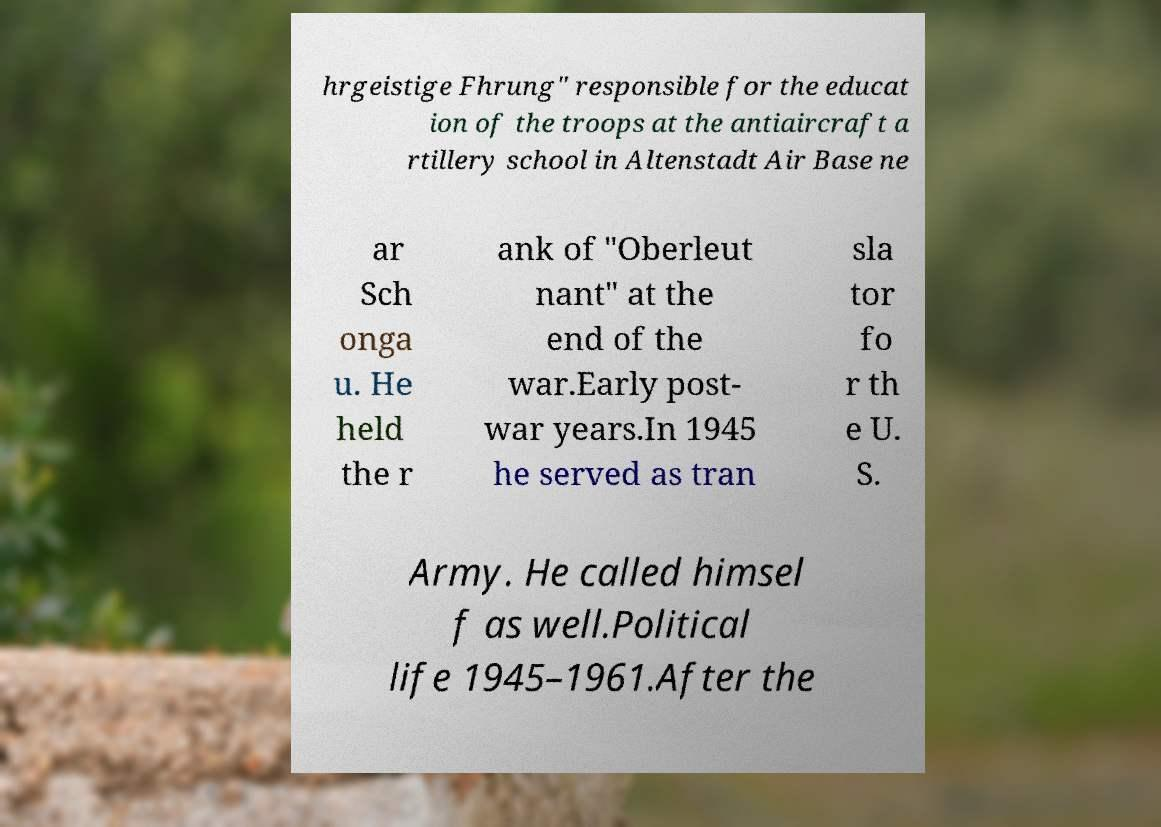Could you extract and type out the text from this image? hrgeistige Fhrung" responsible for the educat ion of the troops at the antiaircraft a rtillery school in Altenstadt Air Base ne ar Sch onga u. He held the r ank of "Oberleut nant" at the end of the war.Early post- war years.In 1945 he served as tran sla tor fo r th e U. S. Army. He called himsel f as well.Political life 1945–1961.After the 